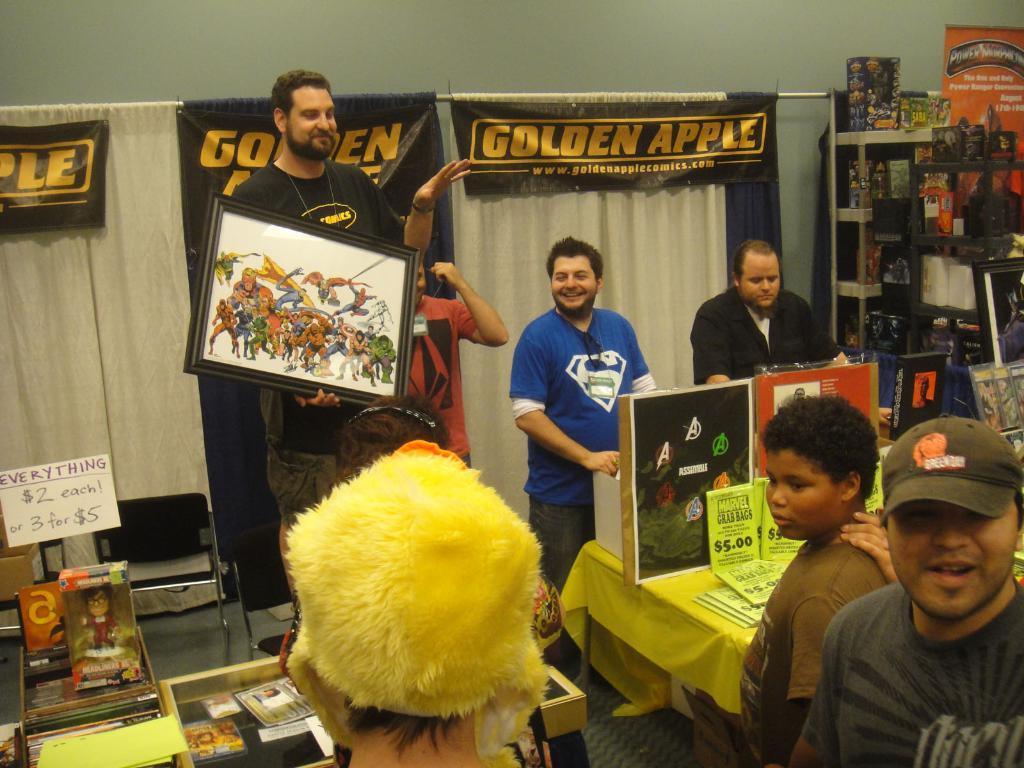Describe this image in one or two sentences. In the image there is a man in black t-shirt holding a painting, on right side of him there are few other man standing, this seems to be clicked in a store, in the back there is a wall with curtains, in the front there are tables with some things and accessories on it, on the right side corner there is rack with many things over it. 